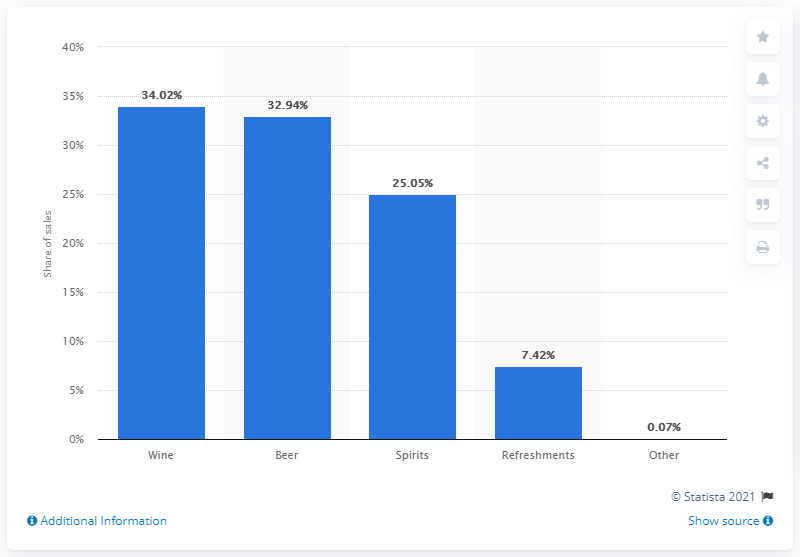Identify some key points in this picture. In the fiscal year ended March 2019, wine accounted for 34.02% of the retail sales of all alcoholic beverages. 